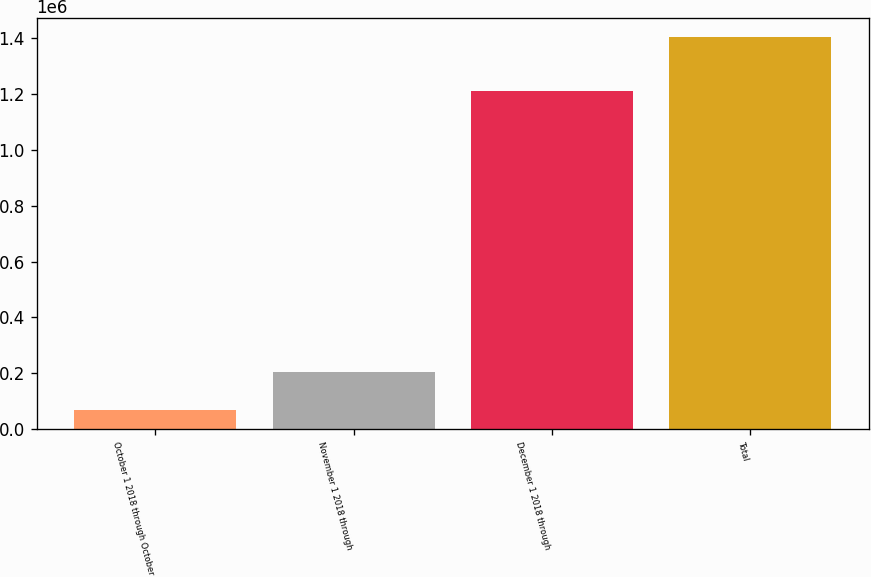Convert chart. <chart><loc_0><loc_0><loc_500><loc_500><bar_chart><fcel>October 1 2018 through October<fcel>November 1 2018 through<fcel>December 1 2018 through<fcel>Total<nl><fcel>69516<fcel>202893<fcel>1.21136e+06<fcel>1.40329e+06<nl></chart> 